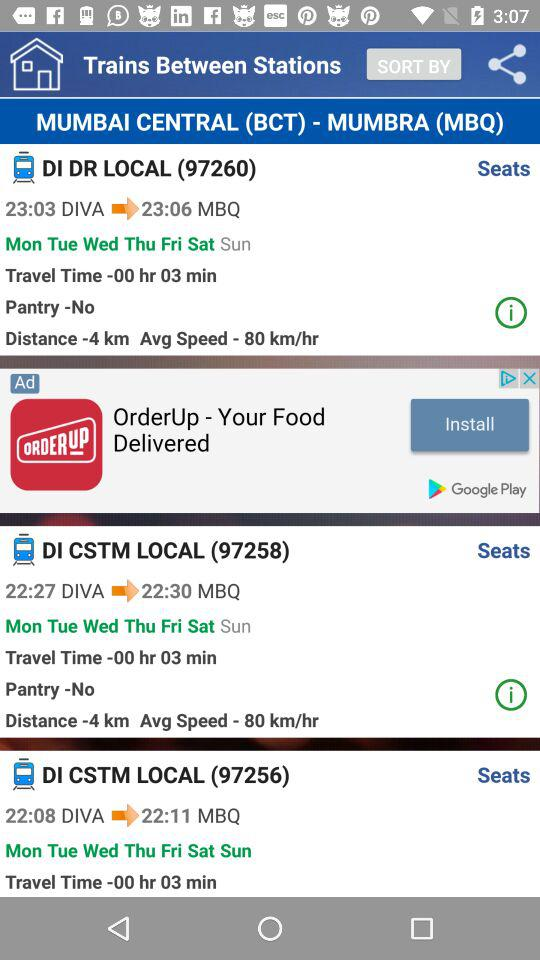What is the average speed of 97258? The average speed of 97258 is 80 km/hr. 